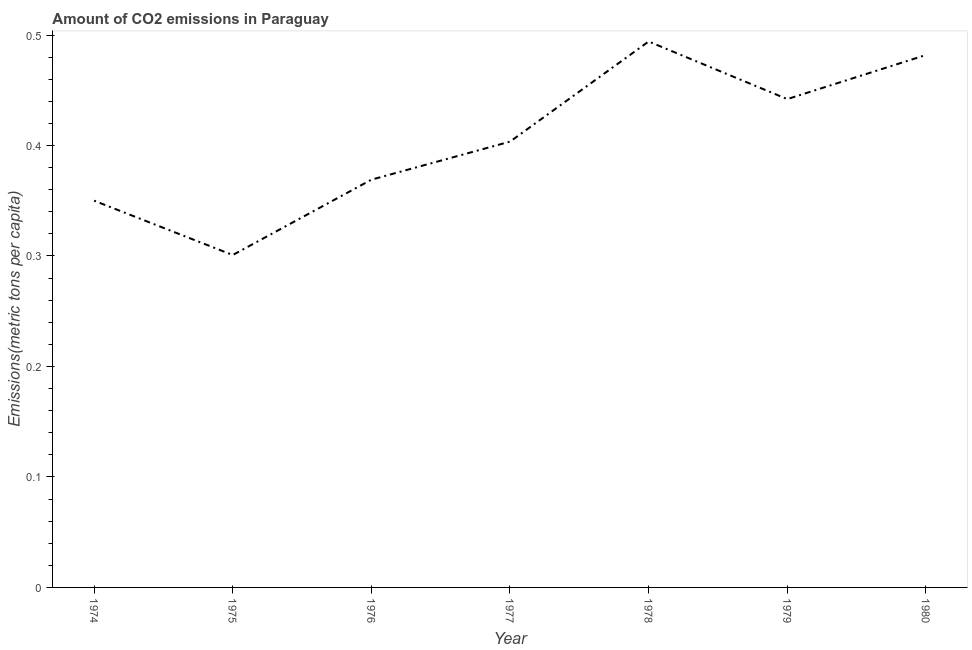What is the amount of co2 emissions in 1976?
Your answer should be compact. 0.37. Across all years, what is the maximum amount of co2 emissions?
Make the answer very short. 0.49. Across all years, what is the minimum amount of co2 emissions?
Your response must be concise. 0.3. In which year was the amount of co2 emissions maximum?
Ensure brevity in your answer.  1978. In which year was the amount of co2 emissions minimum?
Your answer should be compact. 1975. What is the sum of the amount of co2 emissions?
Ensure brevity in your answer.  2.84. What is the difference between the amount of co2 emissions in 1975 and 1978?
Your response must be concise. -0.19. What is the average amount of co2 emissions per year?
Give a very brief answer. 0.41. What is the median amount of co2 emissions?
Offer a very short reply. 0.4. What is the ratio of the amount of co2 emissions in 1974 to that in 1980?
Give a very brief answer. 0.73. Is the amount of co2 emissions in 1978 less than that in 1979?
Your answer should be very brief. No. What is the difference between the highest and the second highest amount of co2 emissions?
Keep it short and to the point. 0.01. What is the difference between the highest and the lowest amount of co2 emissions?
Offer a very short reply. 0.19. In how many years, is the amount of co2 emissions greater than the average amount of co2 emissions taken over all years?
Provide a short and direct response. 3. Are the values on the major ticks of Y-axis written in scientific E-notation?
Make the answer very short. No. Does the graph contain any zero values?
Your answer should be very brief. No. What is the title of the graph?
Offer a very short reply. Amount of CO2 emissions in Paraguay. What is the label or title of the X-axis?
Your answer should be compact. Year. What is the label or title of the Y-axis?
Your answer should be very brief. Emissions(metric tons per capita). What is the Emissions(metric tons per capita) in 1974?
Provide a short and direct response. 0.35. What is the Emissions(metric tons per capita) of 1975?
Give a very brief answer. 0.3. What is the Emissions(metric tons per capita) of 1976?
Offer a terse response. 0.37. What is the Emissions(metric tons per capita) in 1977?
Give a very brief answer. 0.4. What is the Emissions(metric tons per capita) of 1978?
Make the answer very short. 0.49. What is the Emissions(metric tons per capita) in 1979?
Keep it short and to the point. 0.44. What is the Emissions(metric tons per capita) of 1980?
Make the answer very short. 0.48. What is the difference between the Emissions(metric tons per capita) in 1974 and 1975?
Provide a short and direct response. 0.05. What is the difference between the Emissions(metric tons per capita) in 1974 and 1976?
Your response must be concise. -0.02. What is the difference between the Emissions(metric tons per capita) in 1974 and 1977?
Your response must be concise. -0.05. What is the difference between the Emissions(metric tons per capita) in 1974 and 1978?
Your answer should be very brief. -0.14. What is the difference between the Emissions(metric tons per capita) in 1974 and 1979?
Provide a short and direct response. -0.09. What is the difference between the Emissions(metric tons per capita) in 1974 and 1980?
Your response must be concise. -0.13. What is the difference between the Emissions(metric tons per capita) in 1975 and 1976?
Keep it short and to the point. -0.07. What is the difference between the Emissions(metric tons per capita) in 1975 and 1977?
Provide a succinct answer. -0.1. What is the difference between the Emissions(metric tons per capita) in 1975 and 1978?
Your answer should be compact. -0.19. What is the difference between the Emissions(metric tons per capita) in 1975 and 1979?
Your answer should be very brief. -0.14. What is the difference between the Emissions(metric tons per capita) in 1975 and 1980?
Give a very brief answer. -0.18. What is the difference between the Emissions(metric tons per capita) in 1976 and 1977?
Offer a terse response. -0.03. What is the difference between the Emissions(metric tons per capita) in 1976 and 1978?
Your answer should be compact. -0.13. What is the difference between the Emissions(metric tons per capita) in 1976 and 1979?
Your answer should be compact. -0.07. What is the difference between the Emissions(metric tons per capita) in 1976 and 1980?
Offer a terse response. -0.11. What is the difference between the Emissions(metric tons per capita) in 1977 and 1978?
Your answer should be compact. -0.09. What is the difference between the Emissions(metric tons per capita) in 1977 and 1979?
Offer a terse response. -0.04. What is the difference between the Emissions(metric tons per capita) in 1977 and 1980?
Provide a short and direct response. -0.08. What is the difference between the Emissions(metric tons per capita) in 1978 and 1979?
Offer a very short reply. 0.05. What is the difference between the Emissions(metric tons per capita) in 1978 and 1980?
Give a very brief answer. 0.01. What is the difference between the Emissions(metric tons per capita) in 1979 and 1980?
Keep it short and to the point. -0.04. What is the ratio of the Emissions(metric tons per capita) in 1974 to that in 1975?
Make the answer very short. 1.16. What is the ratio of the Emissions(metric tons per capita) in 1974 to that in 1976?
Make the answer very short. 0.95. What is the ratio of the Emissions(metric tons per capita) in 1974 to that in 1977?
Your answer should be very brief. 0.87. What is the ratio of the Emissions(metric tons per capita) in 1974 to that in 1978?
Your answer should be very brief. 0.71. What is the ratio of the Emissions(metric tons per capita) in 1974 to that in 1979?
Your answer should be very brief. 0.79. What is the ratio of the Emissions(metric tons per capita) in 1974 to that in 1980?
Make the answer very short. 0.73. What is the ratio of the Emissions(metric tons per capita) in 1975 to that in 1976?
Your answer should be compact. 0.81. What is the ratio of the Emissions(metric tons per capita) in 1975 to that in 1977?
Ensure brevity in your answer.  0.75. What is the ratio of the Emissions(metric tons per capita) in 1975 to that in 1978?
Provide a succinct answer. 0.61. What is the ratio of the Emissions(metric tons per capita) in 1975 to that in 1979?
Offer a terse response. 0.68. What is the ratio of the Emissions(metric tons per capita) in 1975 to that in 1980?
Ensure brevity in your answer.  0.62. What is the ratio of the Emissions(metric tons per capita) in 1976 to that in 1977?
Your answer should be very brief. 0.92. What is the ratio of the Emissions(metric tons per capita) in 1976 to that in 1978?
Provide a succinct answer. 0.75. What is the ratio of the Emissions(metric tons per capita) in 1976 to that in 1979?
Your answer should be very brief. 0.83. What is the ratio of the Emissions(metric tons per capita) in 1976 to that in 1980?
Provide a succinct answer. 0.77. What is the ratio of the Emissions(metric tons per capita) in 1977 to that in 1978?
Your response must be concise. 0.82. What is the ratio of the Emissions(metric tons per capita) in 1977 to that in 1980?
Your answer should be compact. 0.84. What is the ratio of the Emissions(metric tons per capita) in 1978 to that in 1979?
Make the answer very short. 1.12. What is the ratio of the Emissions(metric tons per capita) in 1979 to that in 1980?
Provide a succinct answer. 0.92. 